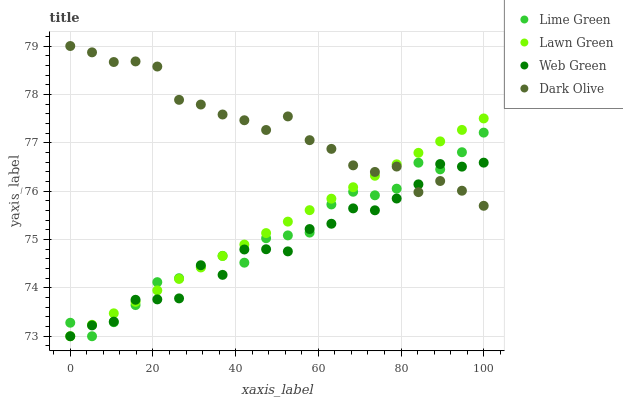Does Web Green have the minimum area under the curve?
Answer yes or no. Yes. Does Dark Olive have the maximum area under the curve?
Answer yes or no. Yes. Does Lime Green have the minimum area under the curve?
Answer yes or no. No. Does Lime Green have the maximum area under the curve?
Answer yes or no. No. Is Lawn Green the smoothest?
Answer yes or no. Yes. Is Web Green the roughest?
Answer yes or no. Yes. Is Dark Olive the smoothest?
Answer yes or no. No. Is Dark Olive the roughest?
Answer yes or no. No. Does Lawn Green have the lowest value?
Answer yes or no. Yes. Does Dark Olive have the lowest value?
Answer yes or no. No. Does Dark Olive have the highest value?
Answer yes or no. Yes. Does Lime Green have the highest value?
Answer yes or no. No. Does Web Green intersect Dark Olive?
Answer yes or no. Yes. Is Web Green less than Dark Olive?
Answer yes or no. No. Is Web Green greater than Dark Olive?
Answer yes or no. No. 